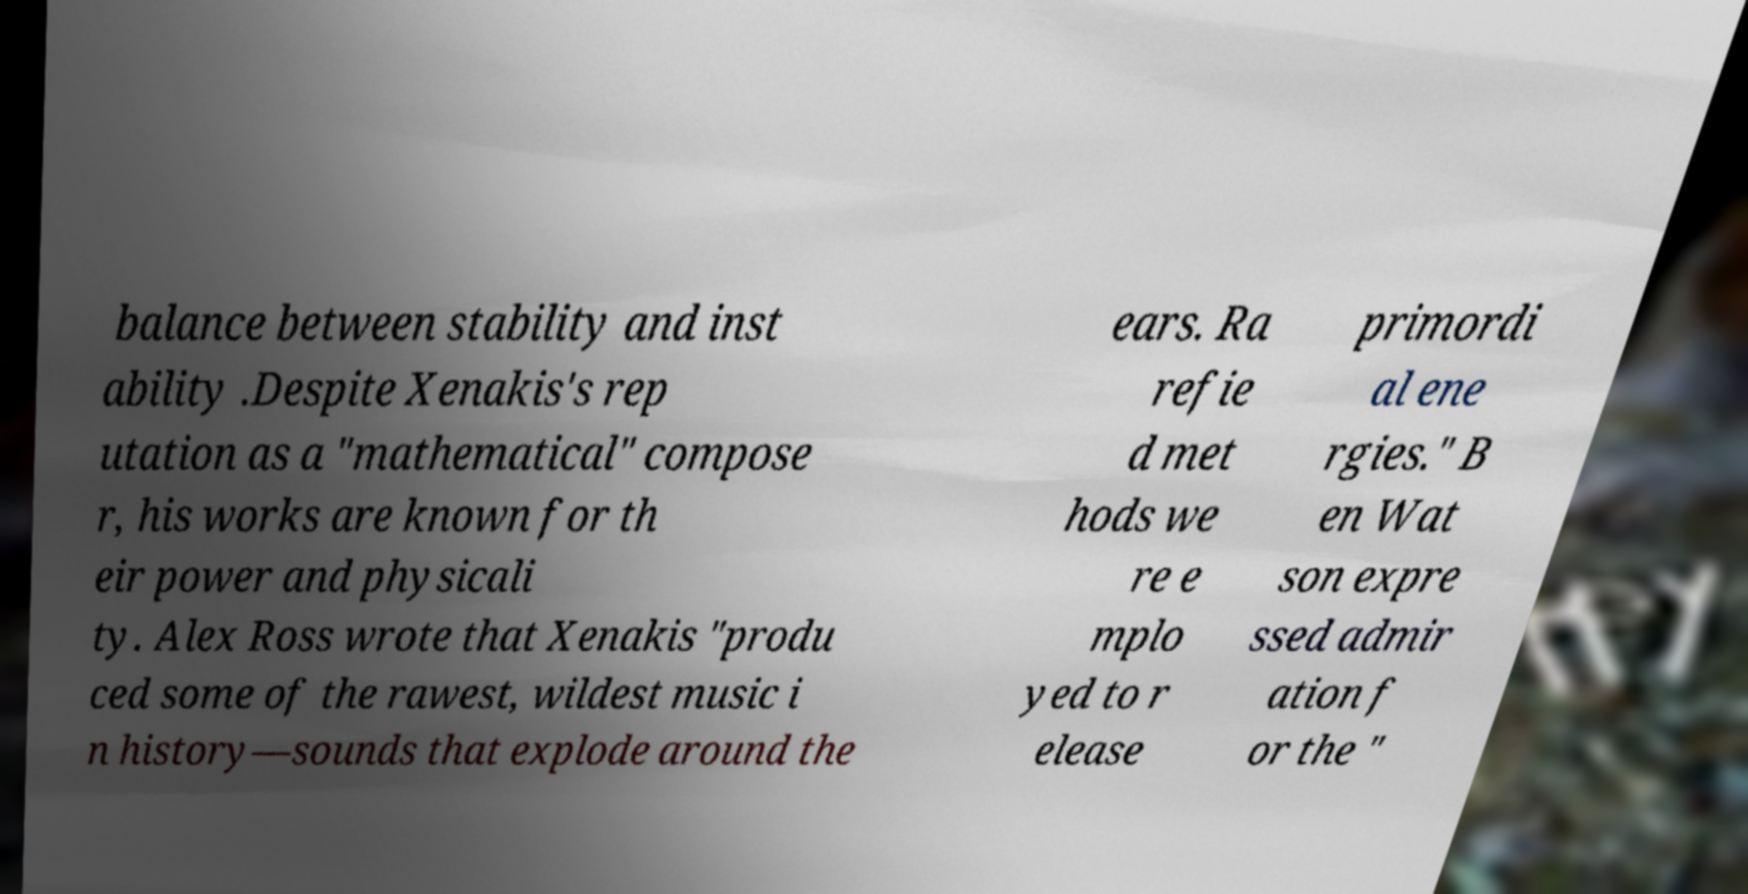Please read and relay the text visible in this image. What does it say? balance between stability and inst ability .Despite Xenakis's rep utation as a "mathematical" compose r, his works are known for th eir power and physicali ty. Alex Ross wrote that Xenakis "produ ced some of the rawest, wildest music i n history—sounds that explode around the ears. Ra refie d met hods we re e mplo yed to r elease primordi al ene rgies." B en Wat son expre ssed admir ation f or the " 